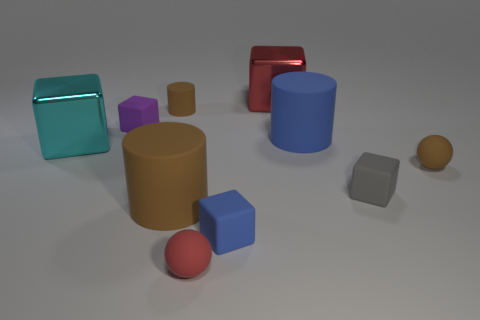Subtract 2 cubes. How many cubes are left? 3 Subtract all small purple rubber cubes. How many cubes are left? 4 Subtract all gray blocks. How many blocks are left? 4 Subtract all green blocks. Subtract all cyan cylinders. How many blocks are left? 5 Subtract all cylinders. How many objects are left? 7 Subtract 0 purple spheres. How many objects are left? 10 Subtract all small brown rubber spheres. Subtract all red rubber balls. How many objects are left? 8 Add 2 tiny brown rubber things. How many tiny brown rubber things are left? 4 Add 8 red metal balls. How many red metal balls exist? 8 